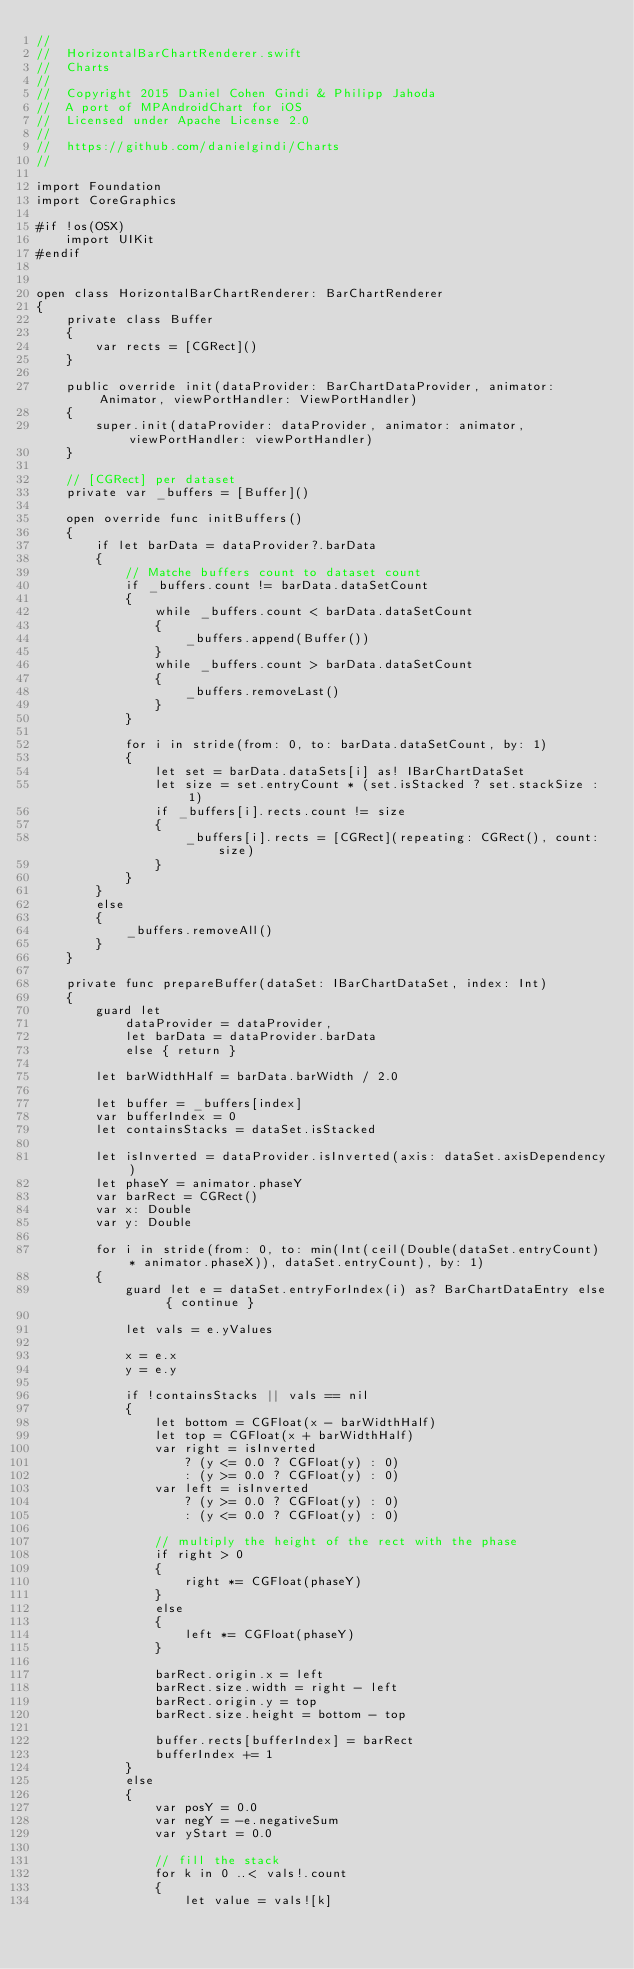Convert code to text. <code><loc_0><loc_0><loc_500><loc_500><_Swift_>//
//  HorizontalBarChartRenderer.swift
//  Charts
//
//  Copyright 2015 Daniel Cohen Gindi & Philipp Jahoda
//  A port of MPAndroidChart for iOS
//  Licensed under Apache License 2.0
//
//  https://github.com/danielgindi/Charts
//

import Foundation
import CoreGraphics

#if !os(OSX)
    import UIKit
#endif


open class HorizontalBarChartRenderer: BarChartRenderer
{
    private class Buffer
    {
        var rects = [CGRect]()
    }
    
    public override init(dataProvider: BarChartDataProvider, animator: Animator, viewPortHandler: ViewPortHandler)
    {
        super.init(dataProvider: dataProvider, animator: animator, viewPortHandler: viewPortHandler)
    }
    
    // [CGRect] per dataset
    private var _buffers = [Buffer]()
    
    open override func initBuffers()
    {
        if let barData = dataProvider?.barData
        {
            // Matche buffers count to dataset count
            if _buffers.count != barData.dataSetCount
            {
                while _buffers.count < barData.dataSetCount
                {
                    _buffers.append(Buffer())
                }
                while _buffers.count > barData.dataSetCount
                {
                    _buffers.removeLast()
                }
            }
            
            for i in stride(from: 0, to: barData.dataSetCount, by: 1)
            {
                let set = barData.dataSets[i] as! IBarChartDataSet
                let size = set.entryCount * (set.isStacked ? set.stackSize : 1)
                if _buffers[i].rects.count != size
                {
                    _buffers[i].rects = [CGRect](repeating: CGRect(), count: size)
                }
            }
        }
        else
        {
            _buffers.removeAll()
        }
    }
    
    private func prepareBuffer(dataSet: IBarChartDataSet, index: Int)
    {
        guard let
            dataProvider = dataProvider,
            let barData = dataProvider.barData
            else { return }
        
        let barWidthHalf = barData.barWidth / 2.0
        
        let buffer = _buffers[index]
        var bufferIndex = 0
        let containsStacks = dataSet.isStacked
        
        let isInverted = dataProvider.isInverted(axis: dataSet.axisDependency)
        let phaseY = animator.phaseY
        var barRect = CGRect()
        var x: Double
        var y: Double
        
        for i in stride(from: 0, to: min(Int(ceil(Double(dataSet.entryCount) * animator.phaseX)), dataSet.entryCount), by: 1)
        {
            guard let e = dataSet.entryForIndex(i) as? BarChartDataEntry else { continue }
            
            let vals = e.yValues
            
            x = e.x
            y = e.y
            
            if !containsStacks || vals == nil
            {
                let bottom = CGFloat(x - barWidthHalf)
                let top = CGFloat(x + barWidthHalf)
                var right = isInverted
                    ? (y <= 0.0 ? CGFloat(y) : 0)
                    : (y >= 0.0 ? CGFloat(y) : 0)
                var left = isInverted
                    ? (y >= 0.0 ? CGFloat(y) : 0)
                    : (y <= 0.0 ? CGFloat(y) : 0)
                
                // multiply the height of the rect with the phase
                if right > 0
                {
                    right *= CGFloat(phaseY)
                }
                else
                {
                    left *= CGFloat(phaseY)
                }
                
                barRect.origin.x = left
                barRect.size.width = right - left
                barRect.origin.y = top
                barRect.size.height = bottom - top
                
                buffer.rects[bufferIndex] = barRect
                bufferIndex += 1
            }
            else
            {
                var posY = 0.0
                var negY = -e.negativeSum
                var yStart = 0.0
                
                // fill the stack
                for k in 0 ..< vals!.count
                {
                    let value = vals![k]
                    </code> 